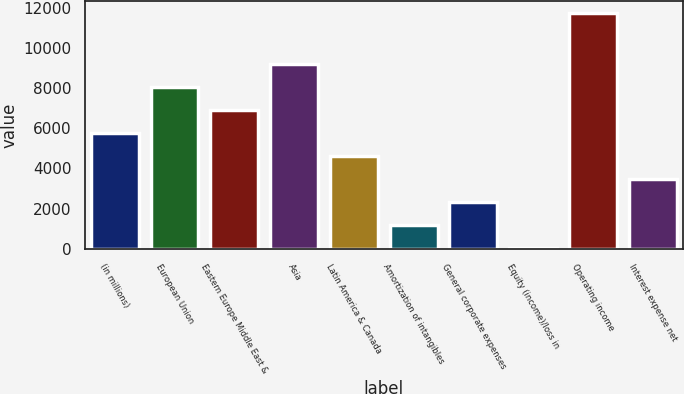<chart> <loc_0><loc_0><loc_500><loc_500><bar_chart><fcel>(in millions)<fcel>European Union<fcel>Eastern Europe Middle East &<fcel>Asia<fcel>Latin America & Canada<fcel>Amortization of intangibles<fcel>General corporate expenses<fcel>Equity (income)/loss in<fcel>Operating income<fcel>Interest expense net<nl><fcel>5781<fcel>8069.8<fcel>6925.4<fcel>9214.2<fcel>4636.6<fcel>1203.4<fcel>2347.8<fcel>59<fcel>11733.4<fcel>3492.2<nl></chart> 